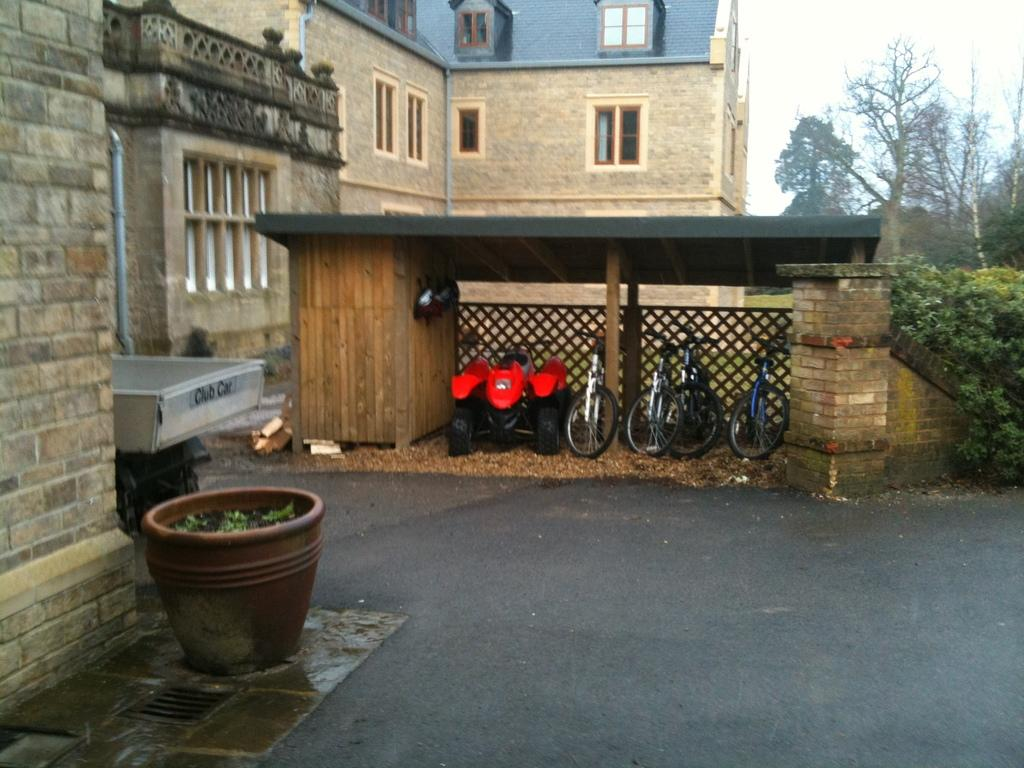What is located at the bottom of the image? There is a road at the bottom of the image. What can be seen in the background of the image? There is a building and trees in the background of the image. What type of structure is present in the image? There is a garage in the image. What is inside the garage? Cycles and other vehicles are inside the garage. Can you see any quicksand on the road in the image? There is no quicksand present on the road in the image. Is there a grandmother balancing a bicycle on her head in the image? There is no grandmother or any person balancing a bicycle on their head in the image. 